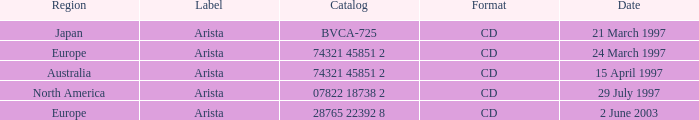What Label has the Region of Australia? Arista. 